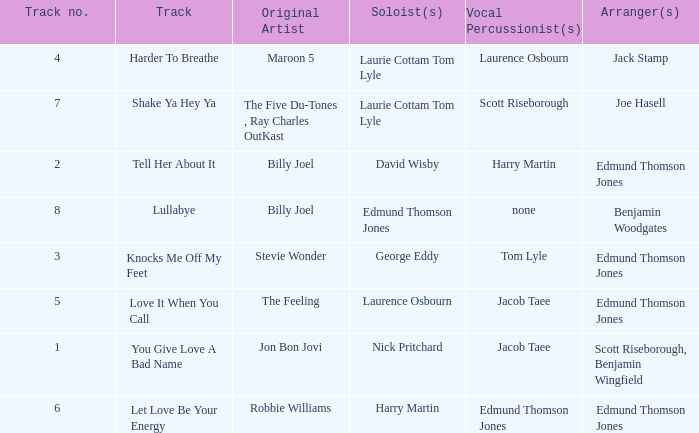Who were the original artist(s) on harder to breathe? Maroon 5. 